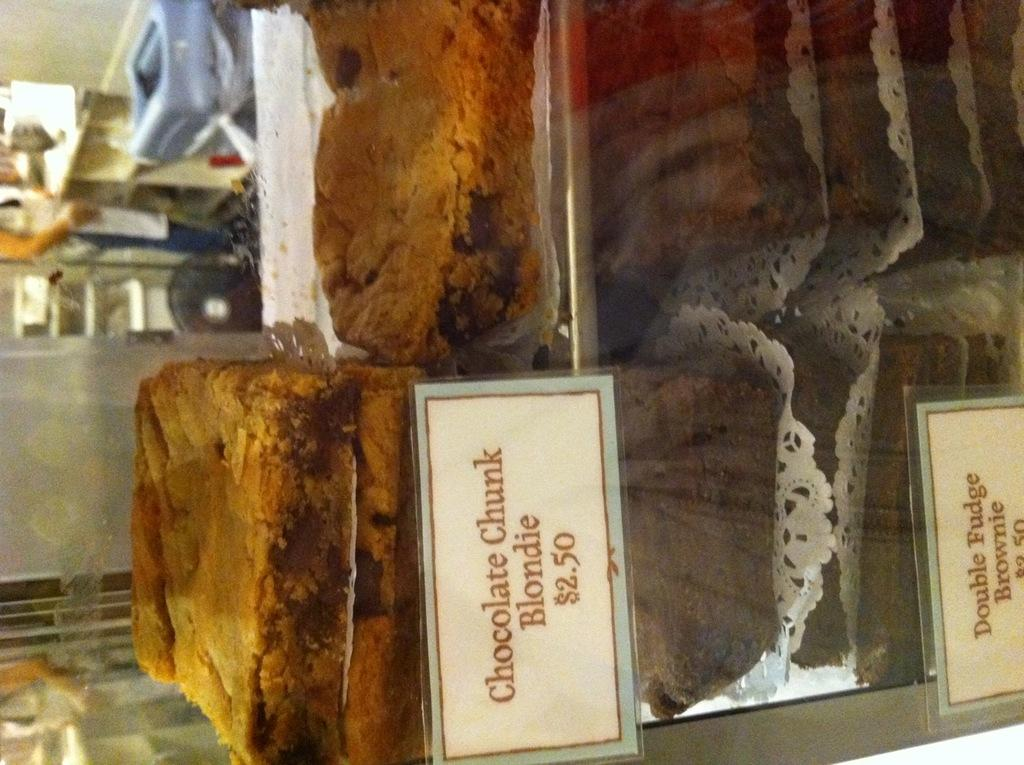What type of food items are visible in the image? There are cakes in the image. What objects are used to identify the cakes in the image? There are name plates in the image to identify the cakes. What type of furniture is visible in the image? There are racks in the image. What type of container is visible in the image? There is a glass in the image. What type of storage furniture is visible in the background towards the left? In the background towards the left, there is a closet. What type of workstation is visible in the background towards the left? In the background towards the left, there is a desk. What type of kitchen equipment is visible in the background towards the left? In the background towards the left, there are kitchen utensils. How much money is owed by the person who baked the cakes in the image? There is no indication of debt or money owed in the image; it only shows cakes, name plates, racks, a glass, and various furniture and equipment in the background. 